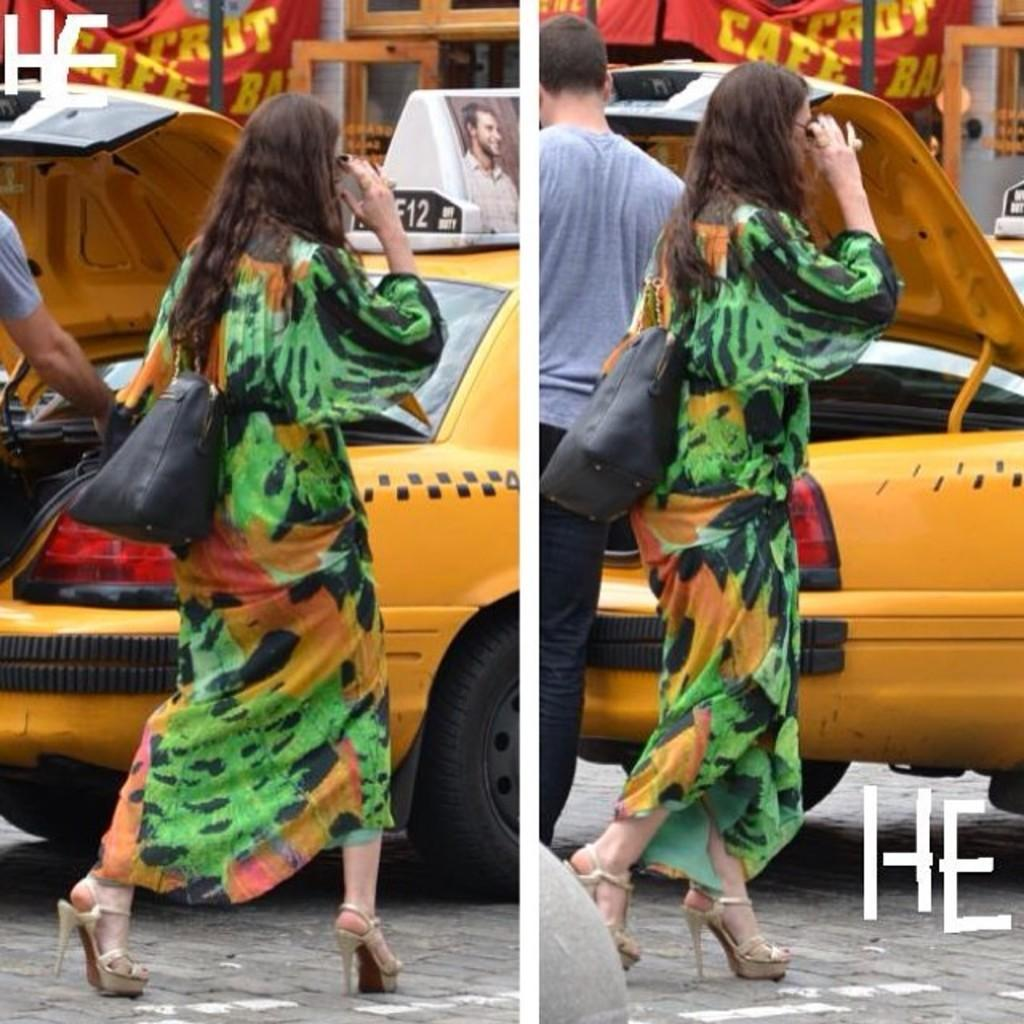<image>
Share a concise interpretation of the image provided. A woman in a green dress is walking by a yellow taxi that is parked under a sign that says Cafe. 